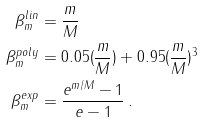Convert formula to latex. <formula><loc_0><loc_0><loc_500><loc_500>\beta ^ { l i n } _ { m } & = \frac { m } { M } \\ \beta ^ { p o l y } _ { m } & = 0 . 0 5 ( \frac { m } { M } ) + 0 . 9 5 ( \frac { m } { M } ) ^ { 3 } \\ \beta ^ { e x p } _ { m } & = \frac { e ^ { m / M } - 1 } { e - 1 } \, .</formula> 